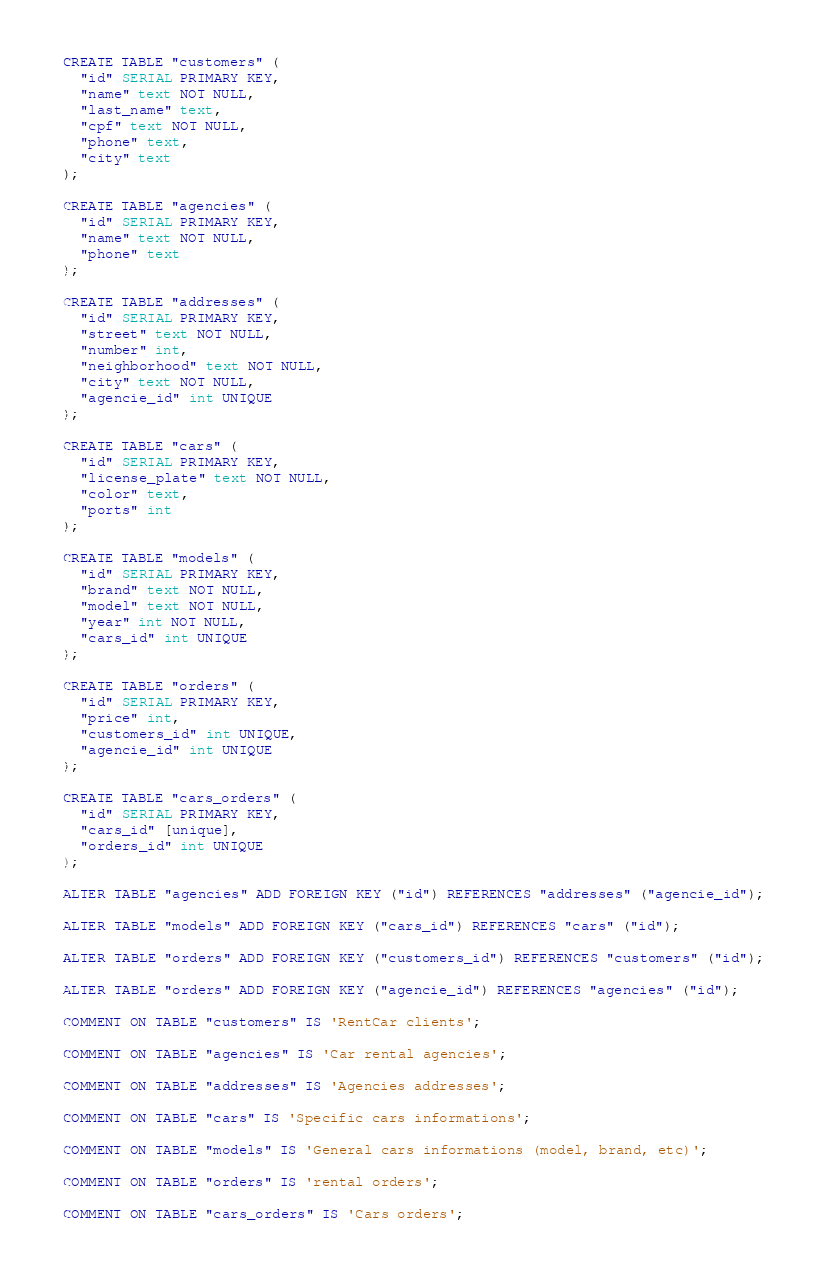Convert code to text. <code><loc_0><loc_0><loc_500><loc_500><_SQL_>CREATE TABLE "customers" (
  "id" SERIAL PRIMARY KEY,
  "name" text NOT NULL,
  "last_name" text,
  "cpf" text NOT NULL,
  "phone" text,
  "city" text
);

CREATE TABLE "agencies" (
  "id" SERIAL PRIMARY KEY,
  "name" text NOT NULL,
  "phone" text
);

CREATE TABLE "addresses" (
  "id" SERIAL PRIMARY KEY,
  "street" text NOT NULL,
  "number" int,
  "neighborhood" text NOT NULL,
  "city" text NOT NULL,
  "agencie_id" int UNIQUE
);

CREATE TABLE "cars" (
  "id" SERIAL PRIMARY KEY,
  "license_plate" text NOT NULL,
  "color" text,
  "ports" int
);

CREATE TABLE "models" (
  "id" SERIAL PRIMARY KEY,
  "brand" text NOT NULL,
  "model" text NOT NULL,
  "year" int NOT NULL,
  "cars_id" int UNIQUE
);

CREATE TABLE "orders" (
  "id" SERIAL PRIMARY KEY,
  "price" int,
  "customers_id" int UNIQUE,
  "agencie_id" int UNIQUE
);

CREATE TABLE "cars_orders" (
  "id" SERIAL PRIMARY KEY,
  "cars_id" [unique],
  "orders_id" int UNIQUE
);

ALTER TABLE "agencies" ADD FOREIGN KEY ("id") REFERENCES "addresses" ("agencie_id");

ALTER TABLE "models" ADD FOREIGN KEY ("cars_id") REFERENCES "cars" ("id");

ALTER TABLE "orders" ADD FOREIGN KEY ("customers_id") REFERENCES "customers" ("id");

ALTER TABLE "orders" ADD FOREIGN KEY ("agencie_id") REFERENCES "agencies" ("id");

COMMENT ON TABLE "customers" IS 'RentCar clients';

COMMENT ON TABLE "agencies" IS 'Car rental agencies';

COMMENT ON TABLE "addresses" IS 'Agencies addresses';

COMMENT ON TABLE "cars" IS 'Specific cars informations';

COMMENT ON TABLE "models" IS 'General cars informations (model, brand, etc)';

COMMENT ON TABLE "orders" IS 'rental orders';

COMMENT ON TABLE "cars_orders" IS 'Cars orders';
</code> 